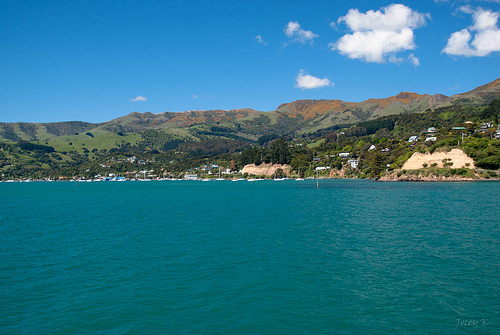<image>
Can you confirm if the house is on the water? No. The house is not positioned on the water. They may be near each other, but the house is not supported by or resting on top of the water. 